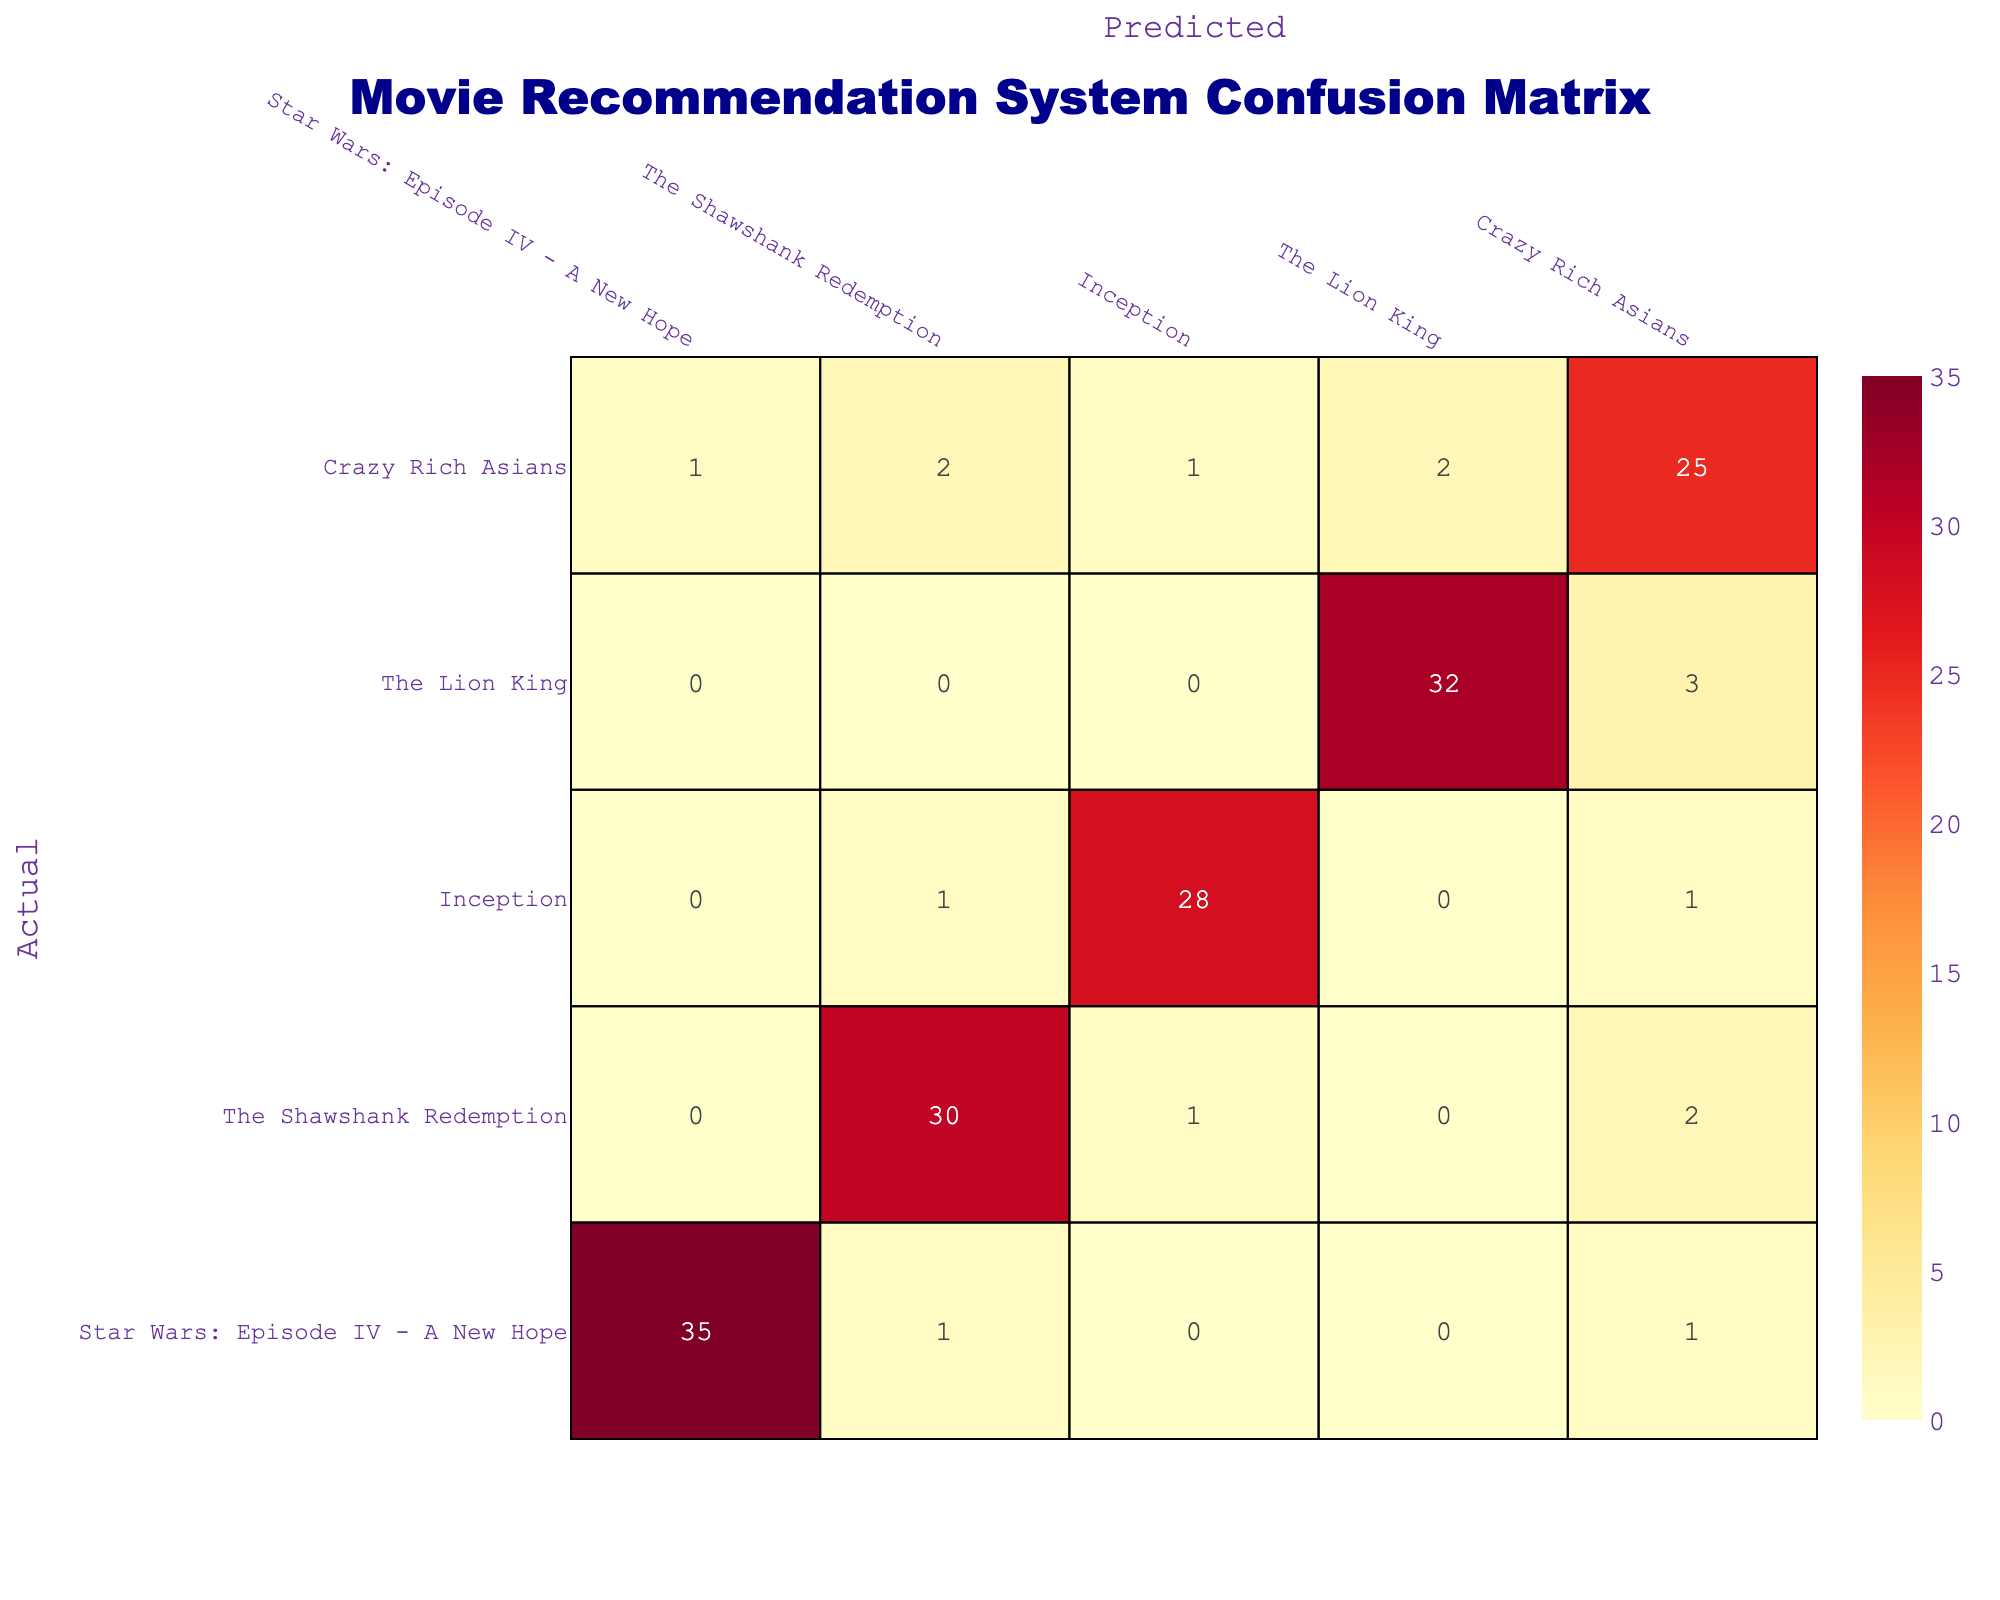How many actual users preferred "The Lion King"? In the "The Lion King" row, the values indicate the actual users’ preferences. To find the total number of actual users who preferred "The Lion King", I look only at its row and sum the values: 0 + 0 + 0 + 32 + 3 = 35.
Answer: 35 What is the total number of times "Inception" was recommended? To find the total number of times "Inception" was recommended, I look at the "Inception" column and sum its values: 0 + 1 + 28 + 0 + 1 = 30.
Answer: 30 Did more users prefer "Star Wars: Episode IV - A New Hope" or "Crazy Rich Asians"? For "Star Wars: Episode IV - A New Hope," the total is 35 (from its row) and for "Crazy Rich Asians," it is 25 (from the corresponding row). Since 35 > 25, more users preferred "Star Wars: Episode IV - A New Hope".
Answer: Yes What is the average number of predictions made for "The Shawshank Redemption"? To find the average predictions made for "The Shawshank Redemption", I sum the predictions in the "The Shawshank Redemption" row: 0 + 30 + 1 + 0 + 2 = 33. There are 5 movies, hence the average is 33 / 5 = 6.6.
Answer: 6.6 Which movie had the highest number of true recommendations (diagonal values)? Looking at the diagonal values: 35 (Star Wars), 30 (Shawshank), 28 (Inception), 32 (Lion King), and 25 (Crazy Rich Asians), "Star Wars: Episode IV - A New Hope" has the highest value at 35.
Answer: Star Wars: Episode IV - A New Hope How many movies had fewer than 30 actual users' preferences? I need to check each movie's total preferences: "The Shawshank Redemption" (33), "Inception" (30), "The Lion King" (35), and "Crazy Rich Asians" (25). Only "Crazy Rich Asians" has fewer than 30, totaling just 25. Therefore, there is 1 movie with fewer.
Answer: 1 What is the total number of incorrect recommendations for "Inception"? "Inception" has predictions of 1 each for "The Shawshank Redemption" and "Crazy Rich Asians", and 0 for the rest. To find incorrect recommendations, I add these values: 1 + 0 + 1 + 0 = 2.
Answer: 2 What is the difference in recommendations between "The Lion King" and "Crazy Rich Asians"? For "The Lion King," the total recommendations, including both correct and incorrect, is 32 + 3 = 35, while for "Crazy Rich Asians," it’s 25 + (1 + 2 + 1 + 2) = 31. Thus, the difference is 35 - 31 = 4.
Answer: 4 